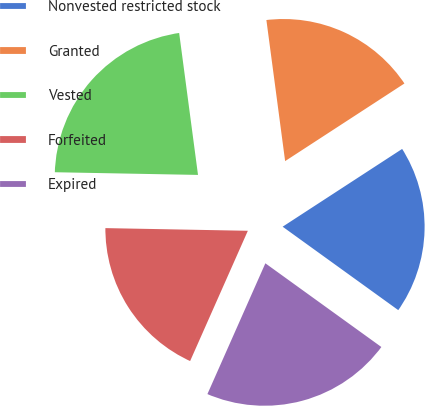Convert chart to OTSL. <chart><loc_0><loc_0><loc_500><loc_500><pie_chart><fcel>Nonvested restricted stock<fcel>Granted<fcel>Vested<fcel>Forfeited<fcel>Expired<nl><fcel>19.13%<fcel>17.92%<fcel>22.6%<fcel>18.66%<fcel>21.69%<nl></chart> 